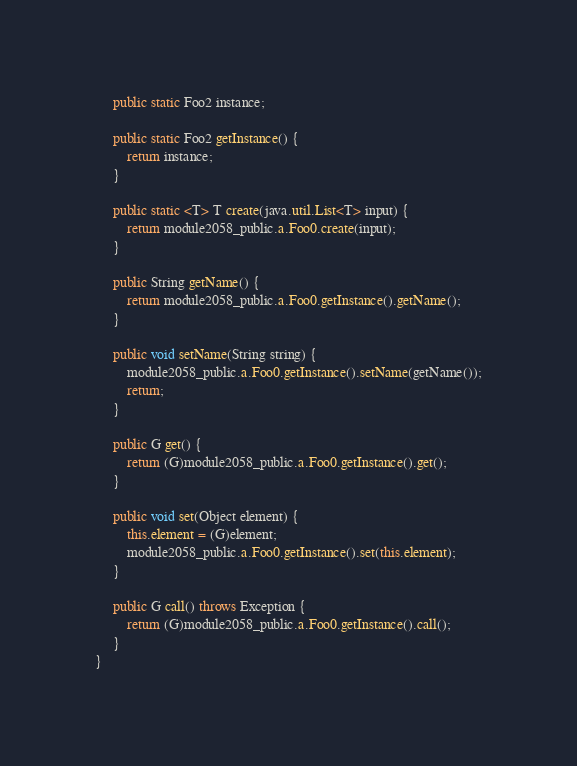<code> <loc_0><loc_0><loc_500><loc_500><_Java_>	 public static Foo2 instance;

	 public static Foo2 getInstance() {
	 	 return instance;
	 }

	 public static <T> T create(java.util.List<T> input) {
	 	 return module2058_public.a.Foo0.create(input);
	 }

	 public String getName() {
	 	 return module2058_public.a.Foo0.getInstance().getName();
	 }

	 public void setName(String string) {
	 	 module2058_public.a.Foo0.getInstance().setName(getName());
	 	 return;
	 }

	 public G get() {
	 	 return (G)module2058_public.a.Foo0.getInstance().get();
	 }

	 public void set(Object element) {
	 	 this.element = (G)element;
	 	 module2058_public.a.Foo0.getInstance().set(this.element);
	 }

	 public G call() throws Exception {
	 	 return (G)module2058_public.a.Foo0.getInstance().call();
	 }
}
</code> 